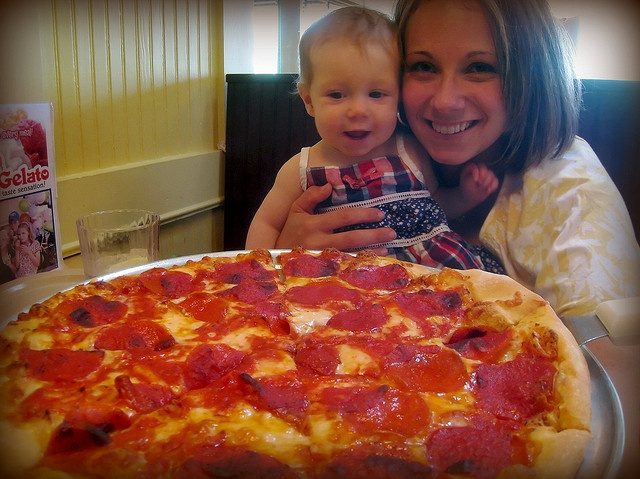Describe the objects in this image and their specific colors. I can see pizza in black, brown, red, and maroon tones, people in black, darkgray, maroon, and tan tones, people in black, brown, and maroon tones, and cup in black, olive, and tan tones in this image. 